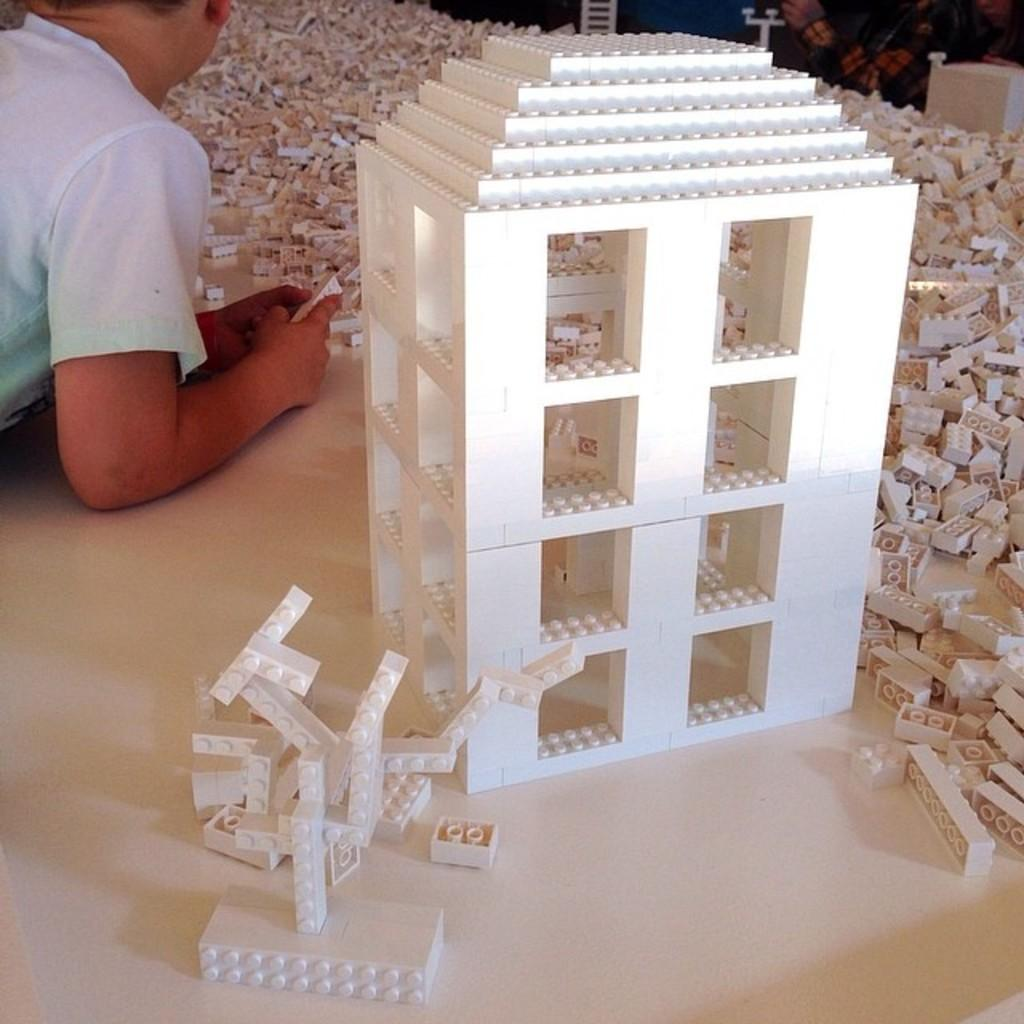What is the main subject of the picture? The main subject of the picture is a Lego set. Who is present in the picture? A child is present in the picture. What is the color of the surface they are on? The surface they are on is white in color. What type of hat is the child wearing in the picture? There is no hat visible in the picture; the child is not wearing one. 